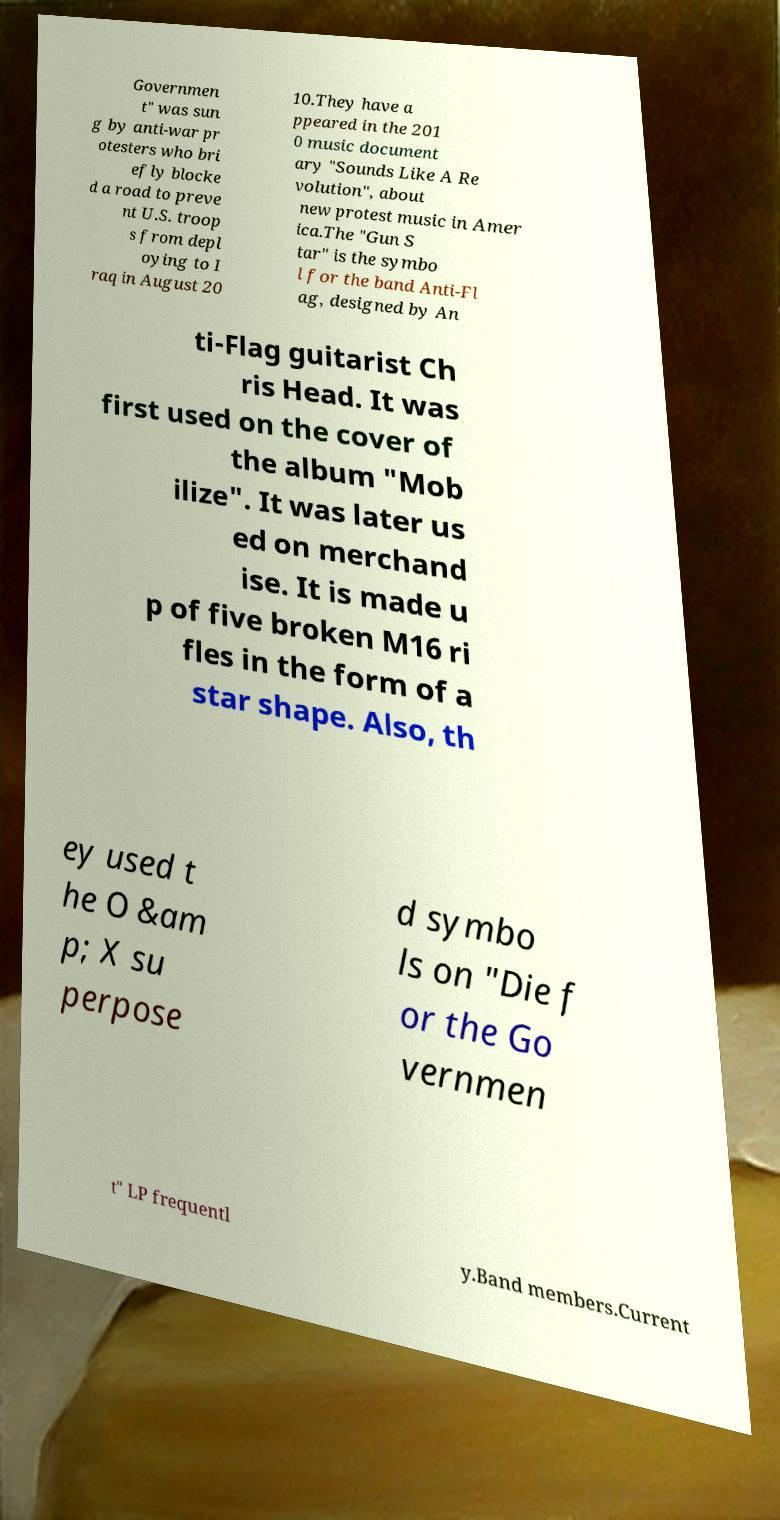Please identify and transcribe the text found in this image. Governmen t" was sun g by anti-war pr otesters who bri efly blocke d a road to preve nt U.S. troop s from depl oying to I raq in August 20 10.They have a ppeared in the 201 0 music document ary "Sounds Like A Re volution", about new protest music in Amer ica.The "Gun S tar" is the symbo l for the band Anti-Fl ag, designed by An ti-Flag guitarist Ch ris Head. It was first used on the cover of the album "Mob ilize". It was later us ed on merchand ise. It is made u p of five broken M16 ri fles in the form of a star shape. Also, th ey used t he O &am p; X su perpose d symbo ls on "Die f or the Go vernmen t" LP frequentl y.Band members.Current 